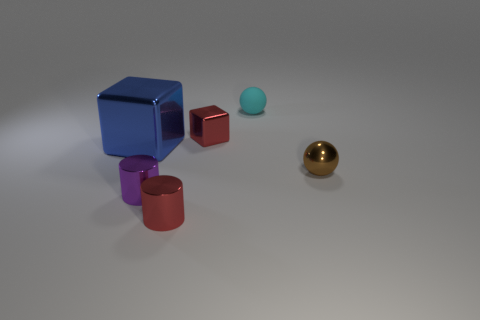What number of things are right of the tiny red shiny thing that is in front of the small brown ball?
Your answer should be compact. 3. What is the shape of the big blue thing?
Give a very brief answer. Cube. There is a purple thing that is made of the same material as the large blue thing; what shape is it?
Give a very brief answer. Cylinder. There is a tiny matte thing that is left of the tiny brown ball; is its shape the same as the large thing?
Provide a succinct answer. No. There is a metallic object on the right side of the cyan matte sphere; what shape is it?
Give a very brief answer. Sphere. What is the shape of the metal object that is the same color as the tiny cube?
Keep it short and to the point. Cylinder. How many other blue objects are the same size as the blue metallic thing?
Offer a very short reply. 0. What is the color of the tiny block?
Your answer should be very brief. Red. There is a big metallic thing; does it have the same color as the shiny cylinder that is in front of the purple thing?
Offer a very short reply. No. There is a blue object that is the same material as the brown sphere; what is its size?
Offer a terse response. Large. 